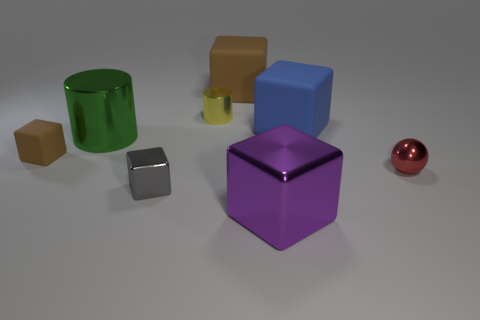How many objects are either blue rubber things to the right of the yellow cylinder or large shiny things that are behind the purple block?
Make the answer very short. 2. Is there anything else that is the same shape as the blue matte thing?
Ensure brevity in your answer.  Yes. What number of purple shiny blocks are there?
Ensure brevity in your answer.  1. Is there a shiny object of the same size as the red shiny sphere?
Give a very brief answer. Yes. Is the big brown object made of the same material as the big thing on the right side of the big purple thing?
Your response must be concise. Yes. Are there the same number of small spheres and large brown matte cylinders?
Ensure brevity in your answer.  No. There is a big thing that is right of the large purple block; what is its material?
Make the answer very short. Rubber. What is the size of the purple metallic object?
Provide a short and direct response. Large. Is the size of the brown rubber block to the right of the small brown object the same as the cylinder in front of the large blue block?
Offer a terse response. Yes. The blue thing that is the same shape as the small gray object is what size?
Ensure brevity in your answer.  Large. 